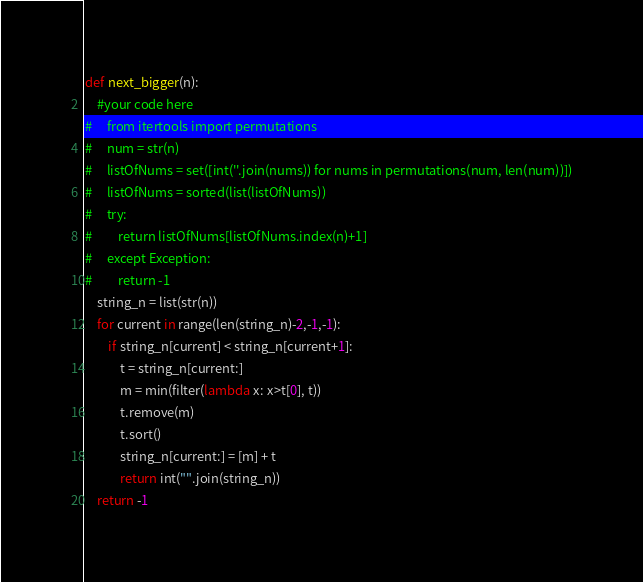<code> <loc_0><loc_0><loc_500><loc_500><_Python_>def next_bigger(n):
    #your code here
#     from itertools import permutations
#     num = str(n)
#     listOfNums = set([int(''.join(nums)) for nums in permutations(num, len(num))])
#     listOfNums = sorted(list(listOfNums))
#     try:
#         return listOfNums[listOfNums.index(n)+1]
#     except Exception:
#         return -1
    string_n = list(str(n))
    for current in range(len(string_n)-2,-1,-1):
        if string_n[current] < string_n[current+1]:
            t = string_n[current:]
            m = min(filter(lambda x: x>t[0], t))
            t.remove(m)
            t.sort()
            string_n[current:] = [m] + t
            return int("".join(string_n))
    return -1
</code> 